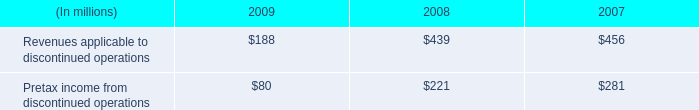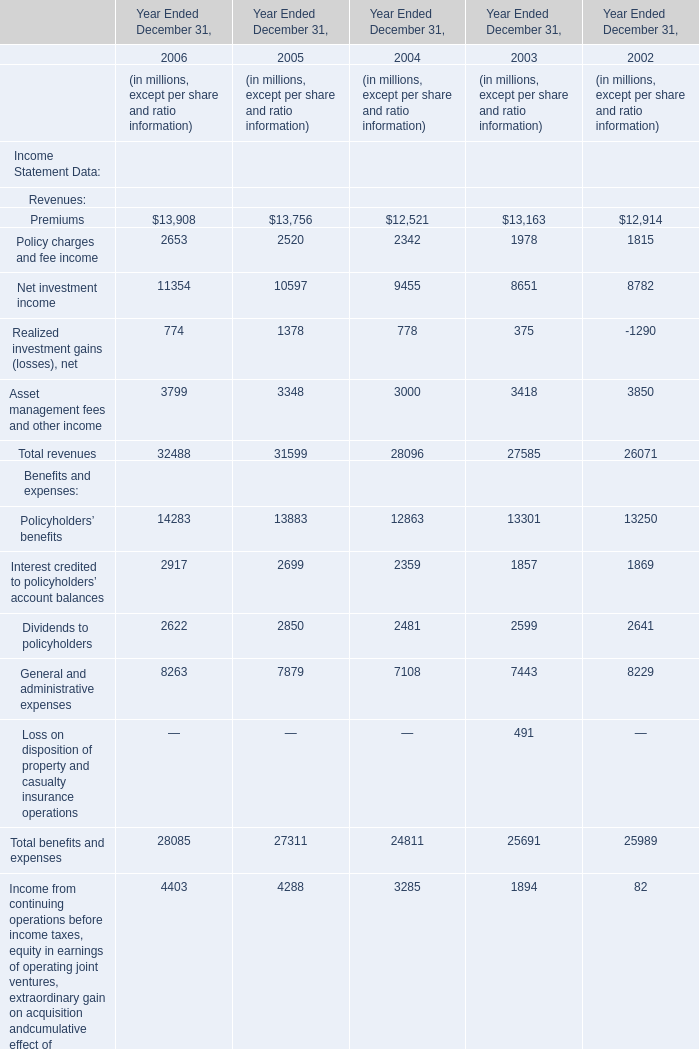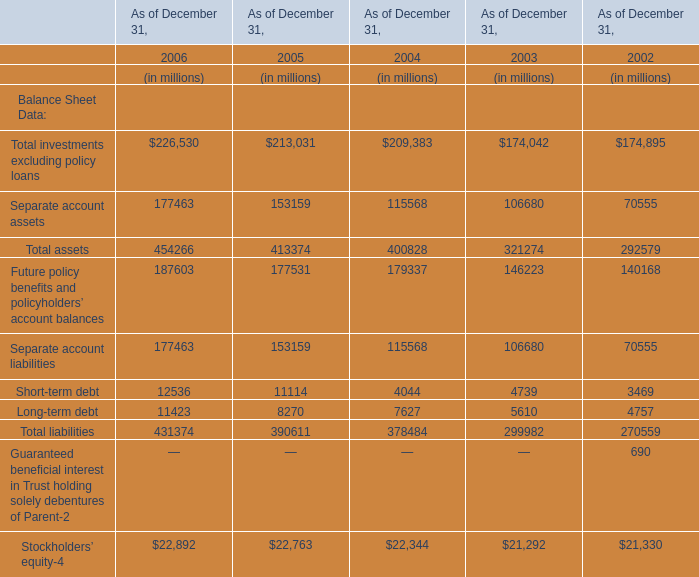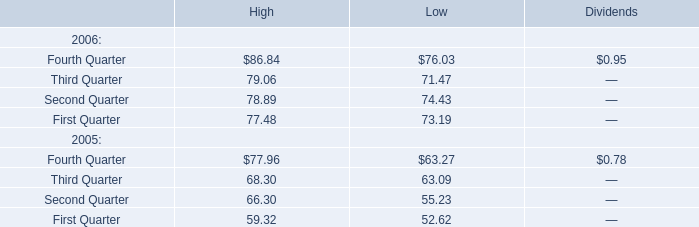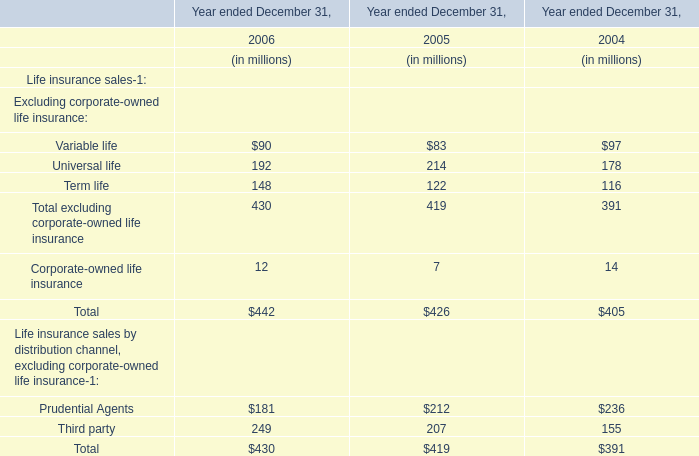What's the total value of all Benefits and expenses that are in the range of 3000 and 15000 in 2005? (in million) 
Computations: (13883 + 7879)
Answer: 21762.0. 